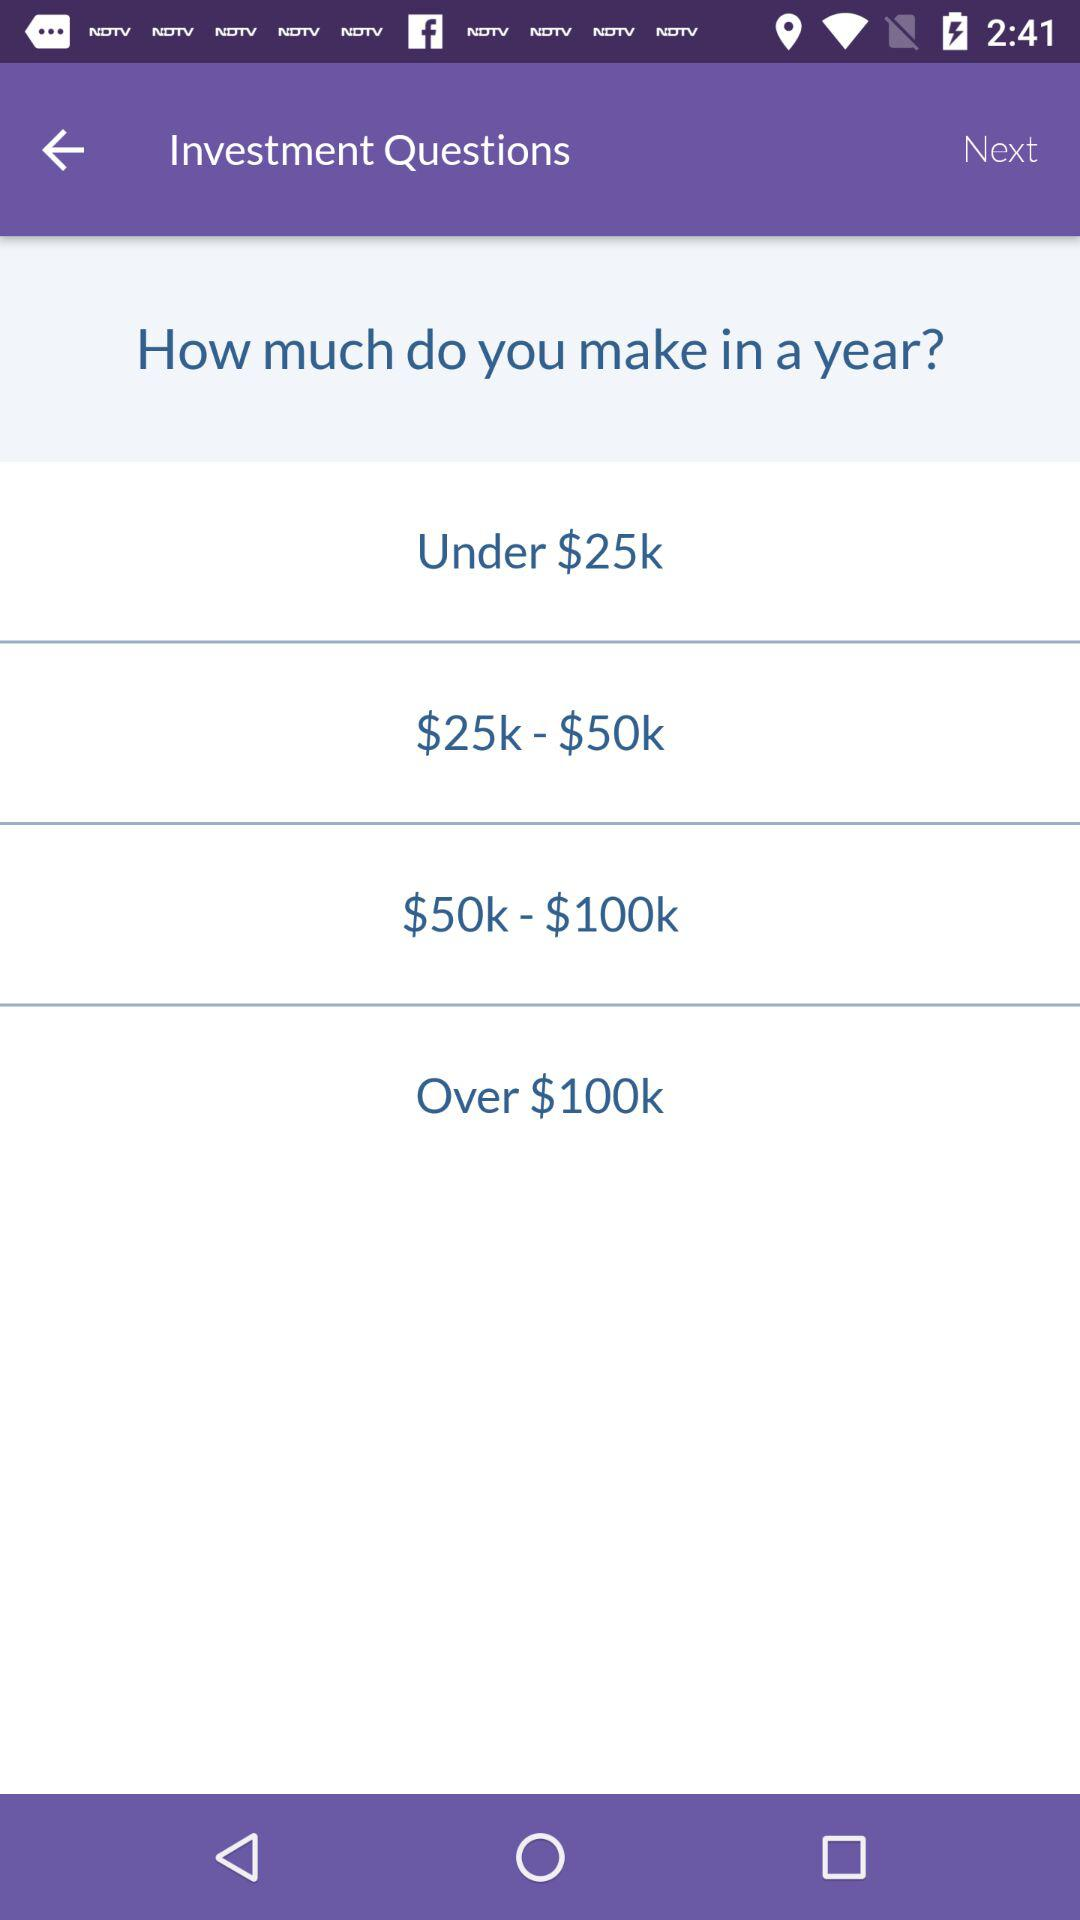How many options are there for the annual income question?
Answer the question using a single word or phrase. 4 